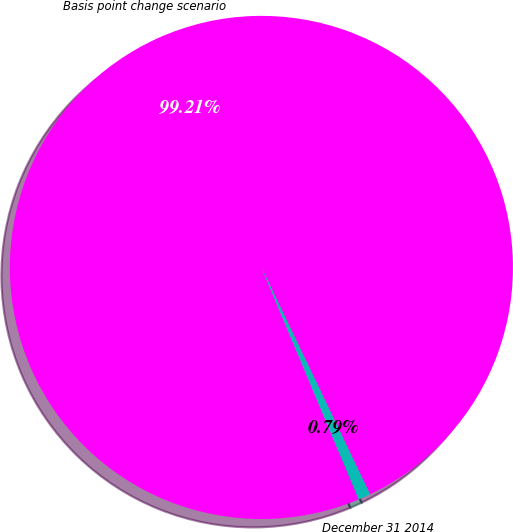Convert chart to OTSL. <chart><loc_0><loc_0><loc_500><loc_500><pie_chart><fcel>Basis point change scenario<fcel>December 31 2014<nl><fcel>99.21%<fcel>0.79%<nl></chart> 